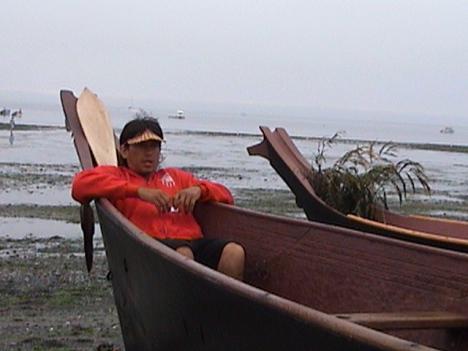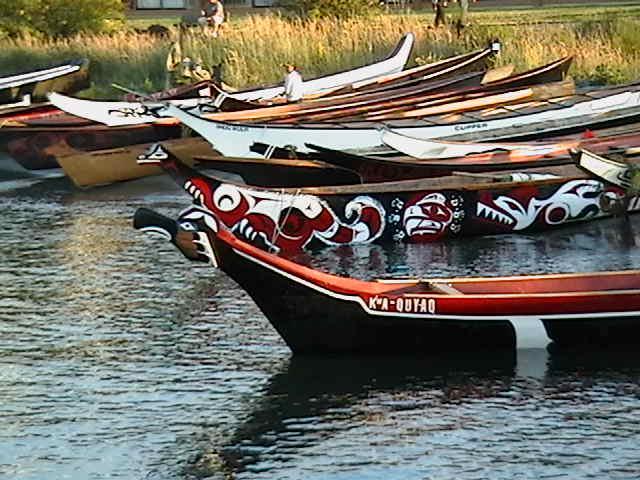The first image is the image on the left, the second image is the image on the right. For the images displayed, is the sentence "In at least one image there are at least three empty boats." factually correct? Answer yes or no. Yes. The first image is the image on the left, the second image is the image on the right. Assess this claim about the two images: "An image shows the tips of at least two reddish-brown boats that are pulled to shore and overlooking the water.". Correct or not? Answer yes or no. Yes. 